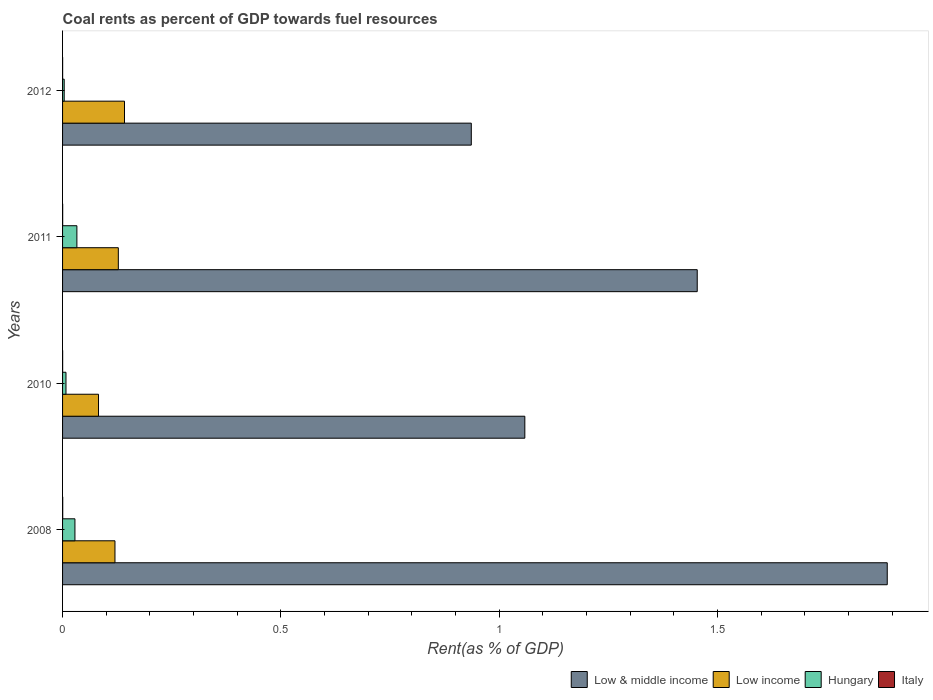How many groups of bars are there?
Provide a short and direct response. 4. Are the number of bars per tick equal to the number of legend labels?
Your answer should be compact. Yes. How many bars are there on the 4th tick from the top?
Provide a succinct answer. 4. How many bars are there on the 1st tick from the bottom?
Provide a short and direct response. 4. In how many cases, is the number of bars for a given year not equal to the number of legend labels?
Your answer should be compact. 0. What is the coal rent in Low & middle income in 2008?
Give a very brief answer. 1.89. Across all years, what is the maximum coal rent in Low & middle income?
Provide a succinct answer. 1.89. Across all years, what is the minimum coal rent in Hungary?
Provide a short and direct response. 0. In which year was the coal rent in Low & middle income maximum?
Ensure brevity in your answer.  2008. In which year was the coal rent in Low & middle income minimum?
Ensure brevity in your answer.  2012. What is the total coal rent in Low & middle income in the graph?
Provide a succinct answer. 5.34. What is the difference between the coal rent in Low income in 2010 and that in 2012?
Your response must be concise. -0.06. What is the difference between the coal rent in Italy in 2008 and the coal rent in Low income in 2012?
Your answer should be very brief. -0.14. What is the average coal rent in Low income per year?
Provide a succinct answer. 0.12. In the year 2012, what is the difference between the coal rent in Low income and coal rent in Low & middle income?
Ensure brevity in your answer.  -0.79. In how many years, is the coal rent in Italy greater than 1.3 %?
Your response must be concise. 0. What is the ratio of the coal rent in Hungary in 2008 to that in 2011?
Offer a terse response. 0.86. Is the coal rent in Hungary in 2008 less than that in 2011?
Offer a terse response. Yes. Is the difference between the coal rent in Low income in 2008 and 2011 greater than the difference between the coal rent in Low & middle income in 2008 and 2011?
Make the answer very short. No. What is the difference between the highest and the second highest coal rent in Low income?
Ensure brevity in your answer.  0.01. What is the difference between the highest and the lowest coal rent in Low & middle income?
Make the answer very short. 0.95. Is the sum of the coal rent in Hungary in 2008 and 2012 greater than the maximum coal rent in Italy across all years?
Keep it short and to the point. Yes. What does the 3rd bar from the bottom in 2012 represents?
Offer a very short reply. Hungary. Is it the case that in every year, the sum of the coal rent in Low & middle income and coal rent in Italy is greater than the coal rent in Hungary?
Give a very brief answer. Yes. Are all the bars in the graph horizontal?
Your answer should be compact. Yes. How many years are there in the graph?
Keep it short and to the point. 4. Does the graph contain any zero values?
Offer a very short reply. No. How many legend labels are there?
Ensure brevity in your answer.  4. How are the legend labels stacked?
Keep it short and to the point. Horizontal. What is the title of the graph?
Your answer should be very brief. Coal rents as percent of GDP towards fuel resources. Does "Monaco" appear as one of the legend labels in the graph?
Provide a succinct answer. No. What is the label or title of the X-axis?
Your answer should be compact. Rent(as % of GDP). What is the Rent(as % of GDP) of Low & middle income in 2008?
Your response must be concise. 1.89. What is the Rent(as % of GDP) in Low income in 2008?
Your answer should be very brief. 0.12. What is the Rent(as % of GDP) of Hungary in 2008?
Provide a succinct answer. 0.03. What is the Rent(as % of GDP) of Italy in 2008?
Give a very brief answer. 0. What is the Rent(as % of GDP) of Low & middle income in 2010?
Your response must be concise. 1.06. What is the Rent(as % of GDP) in Low income in 2010?
Make the answer very short. 0.08. What is the Rent(as % of GDP) of Hungary in 2010?
Offer a terse response. 0.01. What is the Rent(as % of GDP) in Italy in 2010?
Offer a terse response. 0. What is the Rent(as % of GDP) of Low & middle income in 2011?
Provide a short and direct response. 1.45. What is the Rent(as % of GDP) in Low income in 2011?
Your answer should be compact. 0.13. What is the Rent(as % of GDP) in Hungary in 2011?
Make the answer very short. 0.03. What is the Rent(as % of GDP) in Italy in 2011?
Provide a succinct answer. 0. What is the Rent(as % of GDP) in Low & middle income in 2012?
Your response must be concise. 0.94. What is the Rent(as % of GDP) in Low income in 2012?
Give a very brief answer. 0.14. What is the Rent(as % of GDP) in Hungary in 2012?
Give a very brief answer. 0. What is the Rent(as % of GDP) in Italy in 2012?
Keep it short and to the point. 0. Across all years, what is the maximum Rent(as % of GDP) of Low & middle income?
Your answer should be compact. 1.89. Across all years, what is the maximum Rent(as % of GDP) in Low income?
Give a very brief answer. 0.14. Across all years, what is the maximum Rent(as % of GDP) in Hungary?
Your answer should be compact. 0.03. Across all years, what is the maximum Rent(as % of GDP) of Italy?
Offer a very short reply. 0. Across all years, what is the minimum Rent(as % of GDP) of Low & middle income?
Make the answer very short. 0.94. Across all years, what is the minimum Rent(as % of GDP) in Low income?
Your answer should be very brief. 0.08. Across all years, what is the minimum Rent(as % of GDP) of Hungary?
Offer a very short reply. 0. Across all years, what is the minimum Rent(as % of GDP) of Italy?
Provide a short and direct response. 0. What is the total Rent(as % of GDP) of Low & middle income in the graph?
Give a very brief answer. 5.34. What is the total Rent(as % of GDP) in Low income in the graph?
Give a very brief answer. 0.47. What is the total Rent(as % of GDP) of Hungary in the graph?
Keep it short and to the point. 0.07. What is the total Rent(as % of GDP) of Italy in the graph?
Provide a succinct answer. 0. What is the difference between the Rent(as % of GDP) in Low & middle income in 2008 and that in 2010?
Make the answer very short. 0.83. What is the difference between the Rent(as % of GDP) in Low income in 2008 and that in 2010?
Keep it short and to the point. 0.04. What is the difference between the Rent(as % of GDP) in Hungary in 2008 and that in 2010?
Your response must be concise. 0.02. What is the difference between the Rent(as % of GDP) of Italy in 2008 and that in 2010?
Make the answer very short. 0. What is the difference between the Rent(as % of GDP) of Low & middle income in 2008 and that in 2011?
Ensure brevity in your answer.  0.44. What is the difference between the Rent(as % of GDP) of Low income in 2008 and that in 2011?
Provide a succinct answer. -0.01. What is the difference between the Rent(as % of GDP) in Hungary in 2008 and that in 2011?
Ensure brevity in your answer.  -0. What is the difference between the Rent(as % of GDP) of Italy in 2008 and that in 2011?
Make the answer very short. 0. What is the difference between the Rent(as % of GDP) of Low & middle income in 2008 and that in 2012?
Your answer should be compact. 0.95. What is the difference between the Rent(as % of GDP) of Low income in 2008 and that in 2012?
Provide a succinct answer. -0.02. What is the difference between the Rent(as % of GDP) in Hungary in 2008 and that in 2012?
Offer a very short reply. 0.02. What is the difference between the Rent(as % of GDP) in Italy in 2008 and that in 2012?
Make the answer very short. 0. What is the difference between the Rent(as % of GDP) of Low & middle income in 2010 and that in 2011?
Provide a short and direct response. -0.39. What is the difference between the Rent(as % of GDP) of Low income in 2010 and that in 2011?
Your response must be concise. -0.05. What is the difference between the Rent(as % of GDP) in Hungary in 2010 and that in 2011?
Your answer should be very brief. -0.03. What is the difference between the Rent(as % of GDP) in Italy in 2010 and that in 2011?
Provide a short and direct response. -0. What is the difference between the Rent(as % of GDP) of Low & middle income in 2010 and that in 2012?
Keep it short and to the point. 0.12. What is the difference between the Rent(as % of GDP) of Low income in 2010 and that in 2012?
Your answer should be very brief. -0.06. What is the difference between the Rent(as % of GDP) of Hungary in 2010 and that in 2012?
Ensure brevity in your answer.  0. What is the difference between the Rent(as % of GDP) in Low & middle income in 2011 and that in 2012?
Offer a terse response. 0.52. What is the difference between the Rent(as % of GDP) of Low income in 2011 and that in 2012?
Offer a very short reply. -0.01. What is the difference between the Rent(as % of GDP) of Hungary in 2011 and that in 2012?
Offer a terse response. 0.03. What is the difference between the Rent(as % of GDP) in Low & middle income in 2008 and the Rent(as % of GDP) in Low income in 2010?
Your answer should be compact. 1.81. What is the difference between the Rent(as % of GDP) in Low & middle income in 2008 and the Rent(as % of GDP) in Hungary in 2010?
Your response must be concise. 1.88. What is the difference between the Rent(as % of GDP) in Low & middle income in 2008 and the Rent(as % of GDP) in Italy in 2010?
Offer a very short reply. 1.89. What is the difference between the Rent(as % of GDP) of Low income in 2008 and the Rent(as % of GDP) of Hungary in 2010?
Ensure brevity in your answer.  0.11. What is the difference between the Rent(as % of GDP) of Low income in 2008 and the Rent(as % of GDP) of Italy in 2010?
Your response must be concise. 0.12. What is the difference between the Rent(as % of GDP) in Hungary in 2008 and the Rent(as % of GDP) in Italy in 2010?
Keep it short and to the point. 0.03. What is the difference between the Rent(as % of GDP) in Low & middle income in 2008 and the Rent(as % of GDP) in Low income in 2011?
Provide a succinct answer. 1.76. What is the difference between the Rent(as % of GDP) in Low & middle income in 2008 and the Rent(as % of GDP) in Hungary in 2011?
Give a very brief answer. 1.86. What is the difference between the Rent(as % of GDP) in Low & middle income in 2008 and the Rent(as % of GDP) in Italy in 2011?
Keep it short and to the point. 1.89. What is the difference between the Rent(as % of GDP) in Low income in 2008 and the Rent(as % of GDP) in Hungary in 2011?
Provide a short and direct response. 0.09. What is the difference between the Rent(as % of GDP) in Low income in 2008 and the Rent(as % of GDP) in Italy in 2011?
Make the answer very short. 0.12. What is the difference between the Rent(as % of GDP) in Hungary in 2008 and the Rent(as % of GDP) in Italy in 2011?
Your response must be concise. 0.03. What is the difference between the Rent(as % of GDP) in Low & middle income in 2008 and the Rent(as % of GDP) in Low income in 2012?
Give a very brief answer. 1.75. What is the difference between the Rent(as % of GDP) in Low & middle income in 2008 and the Rent(as % of GDP) in Hungary in 2012?
Your response must be concise. 1.88. What is the difference between the Rent(as % of GDP) in Low & middle income in 2008 and the Rent(as % of GDP) in Italy in 2012?
Give a very brief answer. 1.89. What is the difference between the Rent(as % of GDP) in Low income in 2008 and the Rent(as % of GDP) in Hungary in 2012?
Make the answer very short. 0.12. What is the difference between the Rent(as % of GDP) of Low income in 2008 and the Rent(as % of GDP) of Italy in 2012?
Your answer should be very brief. 0.12. What is the difference between the Rent(as % of GDP) in Hungary in 2008 and the Rent(as % of GDP) in Italy in 2012?
Your answer should be compact. 0.03. What is the difference between the Rent(as % of GDP) of Low & middle income in 2010 and the Rent(as % of GDP) of Low income in 2011?
Give a very brief answer. 0.93. What is the difference between the Rent(as % of GDP) of Low & middle income in 2010 and the Rent(as % of GDP) of Hungary in 2011?
Your answer should be compact. 1.03. What is the difference between the Rent(as % of GDP) in Low & middle income in 2010 and the Rent(as % of GDP) in Italy in 2011?
Give a very brief answer. 1.06. What is the difference between the Rent(as % of GDP) in Low income in 2010 and the Rent(as % of GDP) in Hungary in 2011?
Offer a very short reply. 0.05. What is the difference between the Rent(as % of GDP) of Low income in 2010 and the Rent(as % of GDP) of Italy in 2011?
Keep it short and to the point. 0.08. What is the difference between the Rent(as % of GDP) of Hungary in 2010 and the Rent(as % of GDP) of Italy in 2011?
Keep it short and to the point. 0.01. What is the difference between the Rent(as % of GDP) of Low & middle income in 2010 and the Rent(as % of GDP) of Low income in 2012?
Keep it short and to the point. 0.92. What is the difference between the Rent(as % of GDP) of Low & middle income in 2010 and the Rent(as % of GDP) of Hungary in 2012?
Your answer should be compact. 1.05. What is the difference between the Rent(as % of GDP) in Low & middle income in 2010 and the Rent(as % of GDP) in Italy in 2012?
Provide a succinct answer. 1.06. What is the difference between the Rent(as % of GDP) of Low income in 2010 and the Rent(as % of GDP) of Hungary in 2012?
Keep it short and to the point. 0.08. What is the difference between the Rent(as % of GDP) in Low income in 2010 and the Rent(as % of GDP) in Italy in 2012?
Offer a terse response. 0.08. What is the difference between the Rent(as % of GDP) in Hungary in 2010 and the Rent(as % of GDP) in Italy in 2012?
Your answer should be compact. 0.01. What is the difference between the Rent(as % of GDP) in Low & middle income in 2011 and the Rent(as % of GDP) in Low income in 2012?
Your answer should be compact. 1.31. What is the difference between the Rent(as % of GDP) of Low & middle income in 2011 and the Rent(as % of GDP) of Hungary in 2012?
Offer a terse response. 1.45. What is the difference between the Rent(as % of GDP) of Low & middle income in 2011 and the Rent(as % of GDP) of Italy in 2012?
Your answer should be compact. 1.45. What is the difference between the Rent(as % of GDP) in Low income in 2011 and the Rent(as % of GDP) in Hungary in 2012?
Your answer should be very brief. 0.12. What is the difference between the Rent(as % of GDP) in Low income in 2011 and the Rent(as % of GDP) in Italy in 2012?
Keep it short and to the point. 0.13. What is the difference between the Rent(as % of GDP) in Hungary in 2011 and the Rent(as % of GDP) in Italy in 2012?
Ensure brevity in your answer.  0.03. What is the average Rent(as % of GDP) of Low & middle income per year?
Provide a short and direct response. 1.33. What is the average Rent(as % of GDP) of Low income per year?
Your answer should be compact. 0.12. What is the average Rent(as % of GDP) of Hungary per year?
Make the answer very short. 0.02. In the year 2008, what is the difference between the Rent(as % of GDP) in Low & middle income and Rent(as % of GDP) in Low income?
Your answer should be very brief. 1.77. In the year 2008, what is the difference between the Rent(as % of GDP) of Low & middle income and Rent(as % of GDP) of Hungary?
Your answer should be very brief. 1.86. In the year 2008, what is the difference between the Rent(as % of GDP) of Low & middle income and Rent(as % of GDP) of Italy?
Keep it short and to the point. 1.89. In the year 2008, what is the difference between the Rent(as % of GDP) in Low income and Rent(as % of GDP) in Hungary?
Offer a very short reply. 0.09. In the year 2008, what is the difference between the Rent(as % of GDP) of Low income and Rent(as % of GDP) of Italy?
Ensure brevity in your answer.  0.12. In the year 2008, what is the difference between the Rent(as % of GDP) in Hungary and Rent(as % of GDP) in Italy?
Make the answer very short. 0.03. In the year 2010, what is the difference between the Rent(as % of GDP) of Low & middle income and Rent(as % of GDP) of Low income?
Your answer should be compact. 0.98. In the year 2010, what is the difference between the Rent(as % of GDP) in Low & middle income and Rent(as % of GDP) in Hungary?
Provide a short and direct response. 1.05. In the year 2010, what is the difference between the Rent(as % of GDP) of Low & middle income and Rent(as % of GDP) of Italy?
Give a very brief answer. 1.06. In the year 2010, what is the difference between the Rent(as % of GDP) of Low income and Rent(as % of GDP) of Hungary?
Provide a succinct answer. 0.07. In the year 2010, what is the difference between the Rent(as % of GDP) in Low income and Rent(as % of GDP) in Italy?
Keep it short and to the point. 0.08. In the year 2010, what is the difference between the Rent(as % of GDP) of Hungary and Rent(as % of GDP) of Italy?
Offer a terse response. 0.01. In the year 2011, what is the difference between the Rent(as % of GDP) of Low & middle income and Rent(as % of GDP) of Low income?
Provide a succinct answer. 1.33. In the year 2011, what is the difference between the Rent(as % of GDP) of Low & middle income and Rent(as % of GDP) of Hungary?
Keep it short and to the point. 1.42. In the year 2011, what is the difference between the Rent(as % of GDP) of Low & middle income and Rent(as % of GDP) of Italy?
Your response must be concise. 1.45. In the year 2011, what is the difference between the Rent(as % of GDP) of Low income and Rent(as % of GDP) of Hungary?
Provide a succinct answer. 0.09. In the year 2011, what is the difference between the Rent(as % of GDP) of Low income and Rent(as % of GDP) of Italy?
Offer a very short reply. 0.13. In the year 2011, what is the difference between the Rent(as % of GDP) in Hungary and Rent(as % of GDP) in Italy?
Offer a terse response. 0.03. In the year 2012, what is the difference between the Rent(as % of GDP) in Low & middle income and Rent(as % of GDP) in Low income?
Provide a succinct answer. 0.79. In the year 2012, what is the difference between the Rent(as % of GDP) of Low & middle income and Rent(as % of GDP) of Hungary?
Offer a very short reply. 0.93. In the year 2012, what is the difference between the Rent(as % of GDP) in Low & middle income and Rent(as % of GDP) in Italy?
Give a very brief answer. 0.94. In the year 2012, what is the difference between the Rent(as % of GDP) in Low income and Rent(as % of GDP) in Hungary?
Your answer should be compact. 0.14. In the year 2012, what is the difference between the Rent(as % of GDP) of Low income and Rent(as % of GDP) of Italy?
Keep it short and to the point. 0.14. In the year 2012, what is the difference between the Rent(as % of GDP) of Hungary and Rent(as % of GDP) of Italy?
Provide a succinct answer. 0. What is the ratio of the Rent(as % of GDP) in Low & middle income in 2008 to that in 2010?
Your response must be concise. 1.78. What is the ratio of the Rent(as % of GDP) of Low income in 2008 to that in 2010?
Your answer should be compact. 1.46. What is the ratio of the Rent(as % of GDP) in Hungary in 2008 to that in 2010?
Make the answer very short. 3.61. What is the ratio of the Rent(as % of GDP) in Italy in 2008 to that in 2010?
Your response must be concise. 1.89. What is the ratio of the Rent(as % of GDP) in Low & middle income in 2008 to that in 2011?
Keep it short and to the point. 1.3. What is the ratio of the Rent(as % of GDP) of Low income in 2008 to that in 2011?
Make the answer very short. 0.94. What is the ratio of the Rent(as % of GDP) in Hungary in 2008 to that in 2011?
Offer a terse response. 0.86. What is the ratio of the Rent(as % of GDP) in Italy in 2008 to that in 2011?
Offer a terse response. 1.41. What is the ratio of the Rent(as % of GDP) of Low & middle income in 2008 to that in 2012?
Give a very brief answer. 2.02. What is the ratio of the Rent(as % of GDP) of Low income in 2008 to that in 2012?
Provide a succinct answer. 0.85. What is the ratio of the Rent(as % of GDP) of Hungary in 2008 to that in 2012?
Provide a succinct answer. 7.53. What is the ratio of the Rent(as % of GDP) in Italy in 2008 to that in 2012?
Offer a very short reply. 2.48. What is the ratio of the Rent(as % of GDP) in Low & middle income in 2010 to that in 2011?
Ensure brevity in your answer.  0.73. What is the ratio of the Rent(as % of GDP) in Low income in 2010 to that in 2011?
Ensure brevity in your answer.  0.64. What is the ratio of the Rent(as % of GDP) in Hungary in 2010 to that in 2011?
Provide a short and direct response. 0.24. What is the ratio of the Rent(as % of GDP) in Italy in 2010 to that in 2011?
Provide a succinct answer. 0.75. What is the ratio of the Rent(as % of GDP) in Low & middle income in 2010 to that in 2012?
Provide a succinct answer. 1.13. What is the ratio of the Rent(as % of GDP) of Low income in 2010 to that in 2012?
Your answer should be very brief. 0.58. What is the ratio of the Rent(as % of GDP) of Hungary in 2010 to that in 2012?
Provide a short and direct response. 2.08. What is the ratio of the Rent(as % of GDP) in Italy in 2010 to that in 2012?
Make the answer very short. 1.31. What is the ratio of the Rent(as % of GDP) of Low & middle income in 2011 to that in 2012?
Your answer should be very brief. 1.55. What is the ratio of the Rent(as % of GDP) in Low income in 2011 to that in 2012?
Your response must be concise. 0.9. What is the ratio of the Rent(as % of GDP) of Hungary in 2011 to that in 2012?
Keep it short and to the point. 8.72. What is the ratio of the Rent(as % of GDP) of Italy in 2011 to that in 2012?
Give a very brief answer. 1.76. What is the difference between the highest and the second highest Rent(as % of GDP) of Low & middle income?
Ensure brevity in your answer.  0.44. What is the difference between the highest and the second highest Rent(as % of GDP) in Low income?
Offer a terse response. 0.01. What is the difference between the highest and the second highest Rent(as % of GDP) of Hungary?
Provide a short and direct response. 0. What is the difference between the highest and the lowest Rent(as % of GDP) of Low & middle income?
Your answer should be very brief. 0.95. What is the difference between the highest and the lowest Rent(as % of GDP) of Low income?
Make the answer very short. 0.06. What is the difference between the highest and the lowest Rent(as % of GDP) in Hungary?
Offer a terse response. 0.03. What is the difference between the highest and the lowest Rent(as % of GDP) in Italy?
Ensure brevity in your answer.  0. 